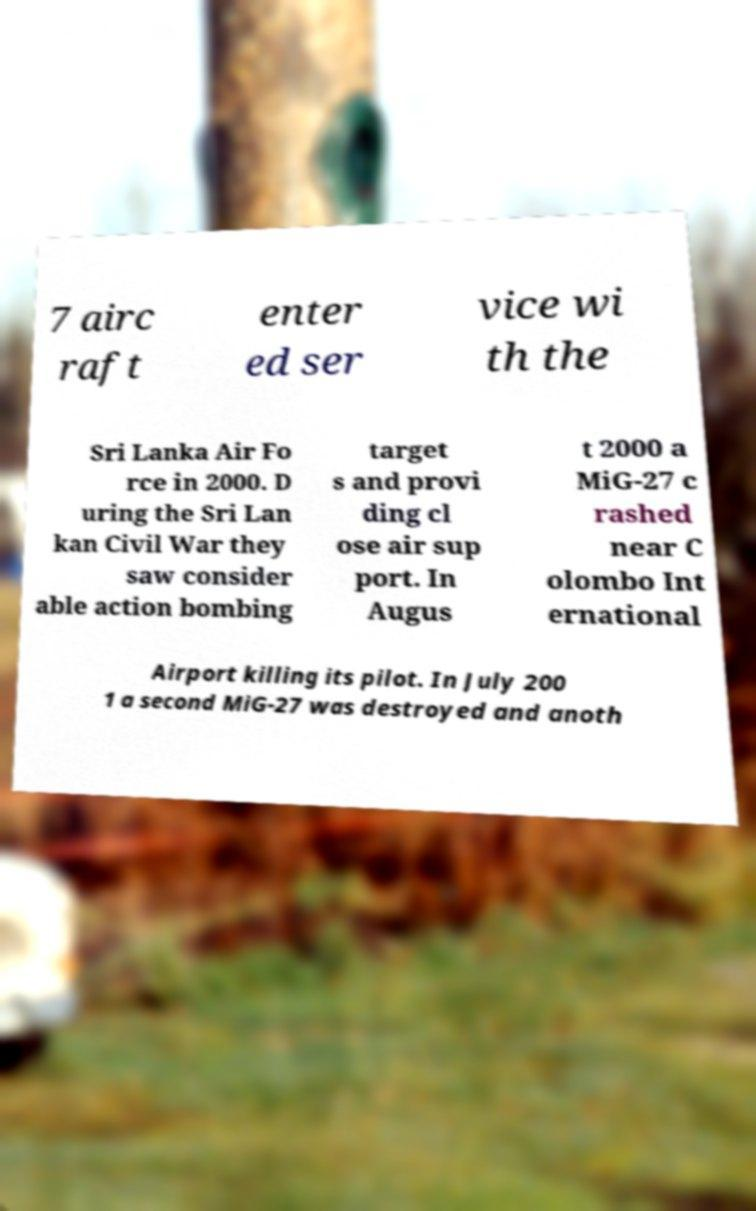Can you accurately transcribe the text from the provided image for me? 7 airc raft enter ed ser vice wi th the Sri Lanka Air Fo rce in 2000. D uring the Sri Lan kan Civil War they saw consider able action bombing target s and provi ding cl ose air sup port. In Augus t 2000 a MiG-27 c rashed near C olombo Int ernational Airport killing its pilot. In July 200 1 a second MiG-27 was destroyed and anoth 